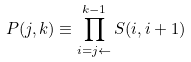<formula> <loc_0><loc_0><loc_500><loc_500>P ( j , k ) \equiv \prod _ { i = j \leftarrow } ^ { k - 1 } S ( i , i + 1 )</formula> 